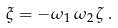Convert formula to latex. <formula><loc_0><loc_0><loc_500><loc_500>\xi = - \omega _ { 1 } \, \omega _ { 2 } \, \zeta \, .</formula> 